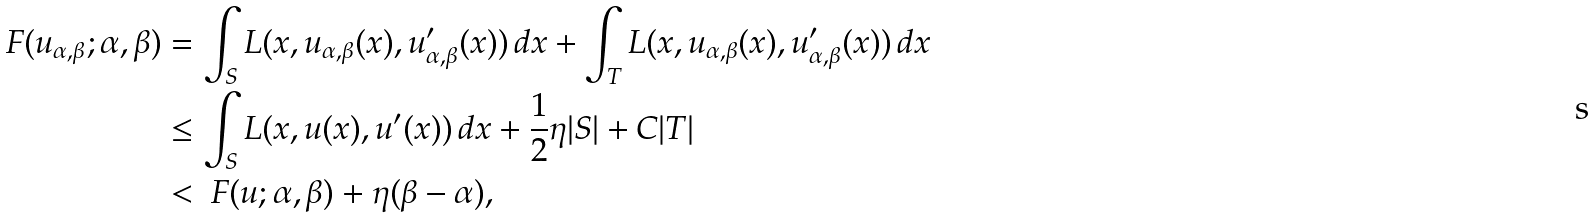<formula> <loc_0><loc_0><loc_500><loc_500>\ F ( u _ { \alpha , \beta } ; \alpha , \beta ) & = \int _ { S } L ( x , u _ { \alpha , \beta } ( x ) , u _ { \alpha , \beta } ^ { \prime } ( x ) ) \, d x + \int _ { T } L ( x , u _ { \alpha , \beta } ( x ) , u _ { \alpha , \beta } ^ { \prime } ( x ) ) \, d x \\ & \leq \int _ { S } L ( x , u ( x ) , u ^ { \prime } ( x ) ) \, d x + \frac { 1 } { 2 } \eta | S | + C | T | \\ & < \ F ( u ; \alpha , \beta ) + \eta ( \beta - \alpha ) ,</formula> 